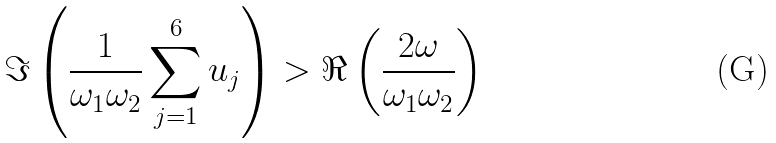Convert formula to latex. <formula><loc_0><loc_0><loc_500><loc_500>\Im \left ( \frac { 1 } { \omega _ { 1 } \omega _ { 2 } } \sum _ { j = 1 } ^ { 6 } u _ { j } \right ) > \Re \left ( \frac { 2 \omega } { \omega _ { 1 } \omega _ { 2 } } \right )</formula> 